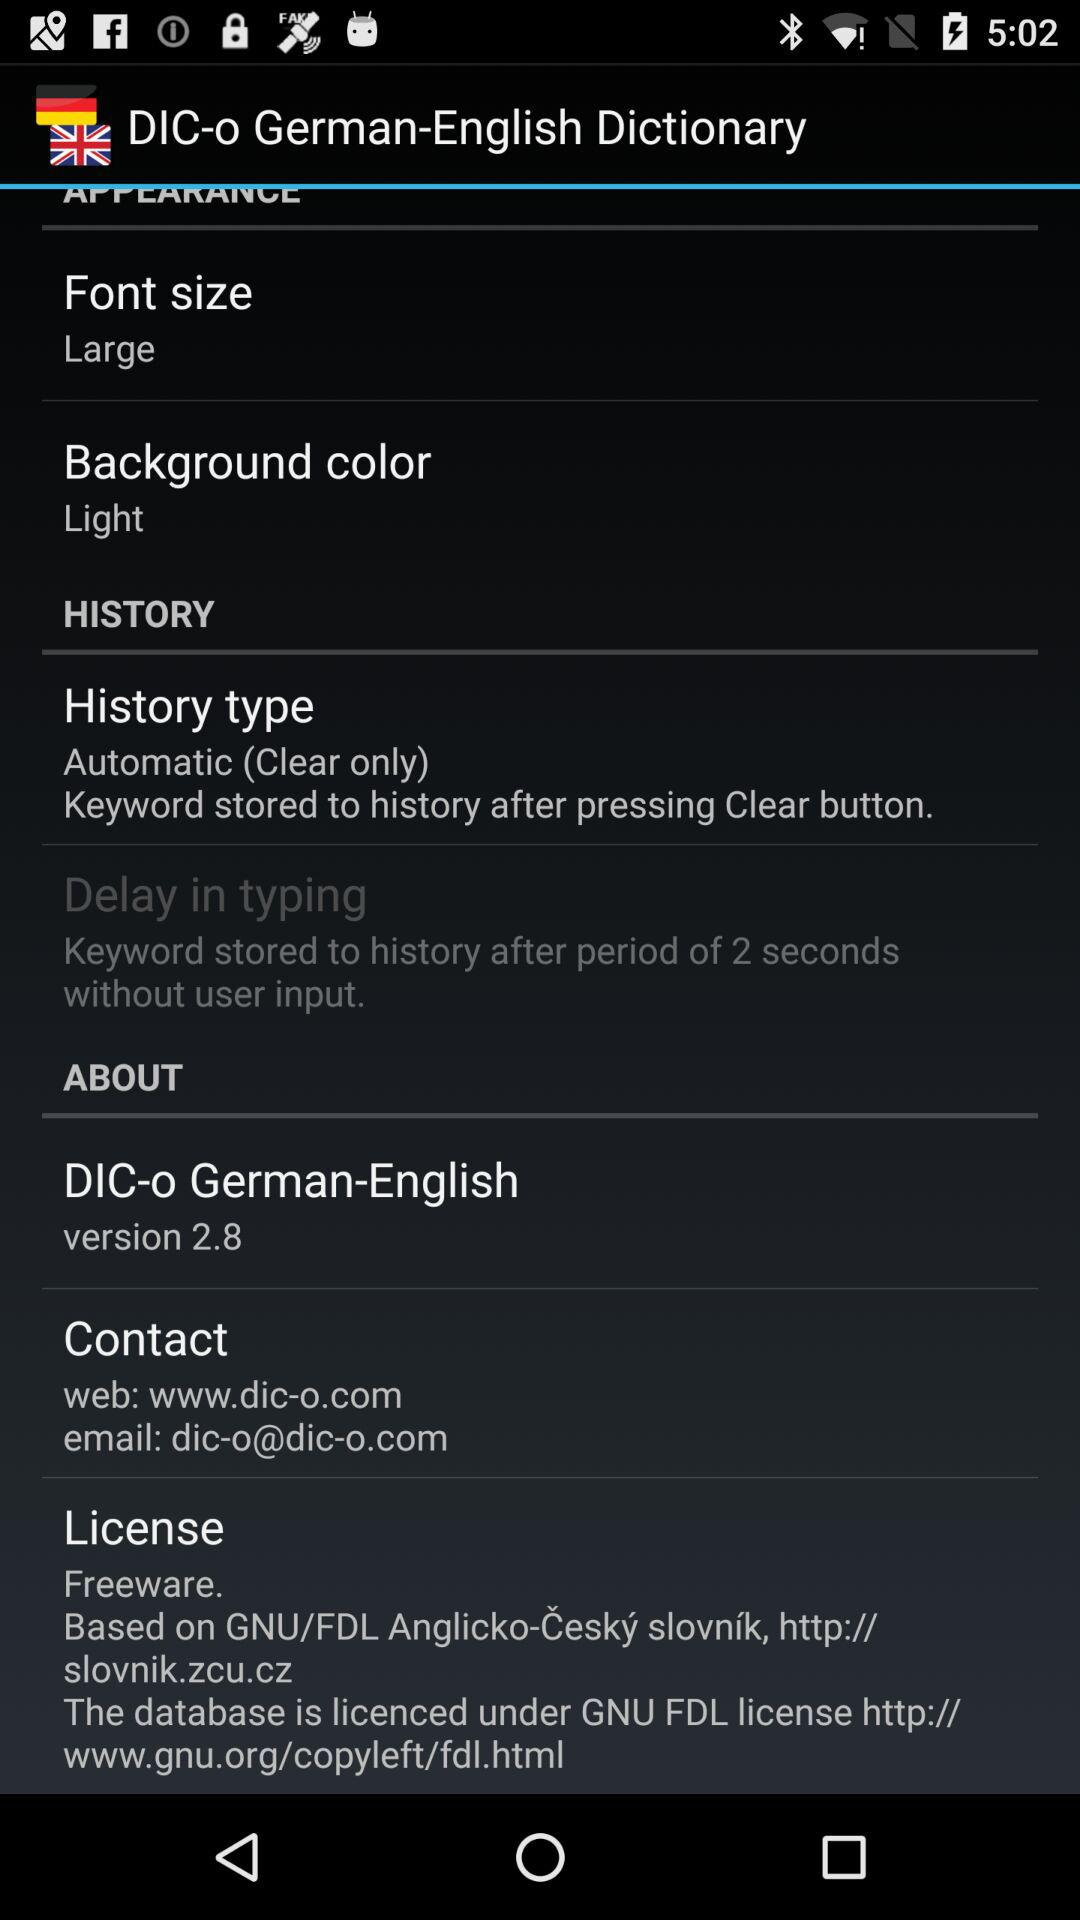What is the email address? The email address is dic-o@dic-o.com. 